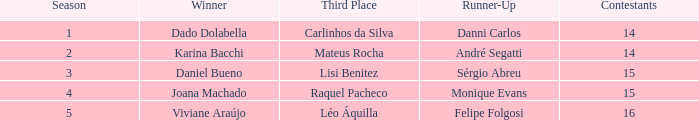Who finished in third place when the winner was Karina Bacchi?  Mateus Rocha. 